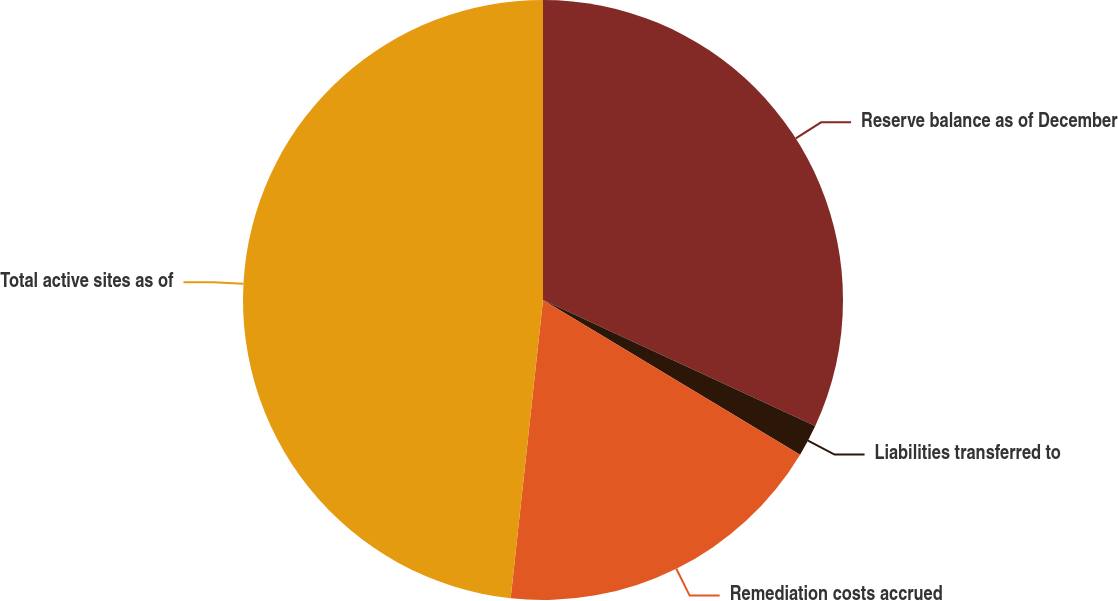Convert chart to OTSL. <chart><loc_0><loc_0><loc_500><loc_500><pie_chart><fcel>Reserve balance as of December<fcel>Liabilities transferred to<fcel>Remediation costs accrued<fcel>Total active sites as of<nl><fcel>31.9%<fcel>1.72%<fcel>18.1%<fcel>48.28%<nl></chart> 